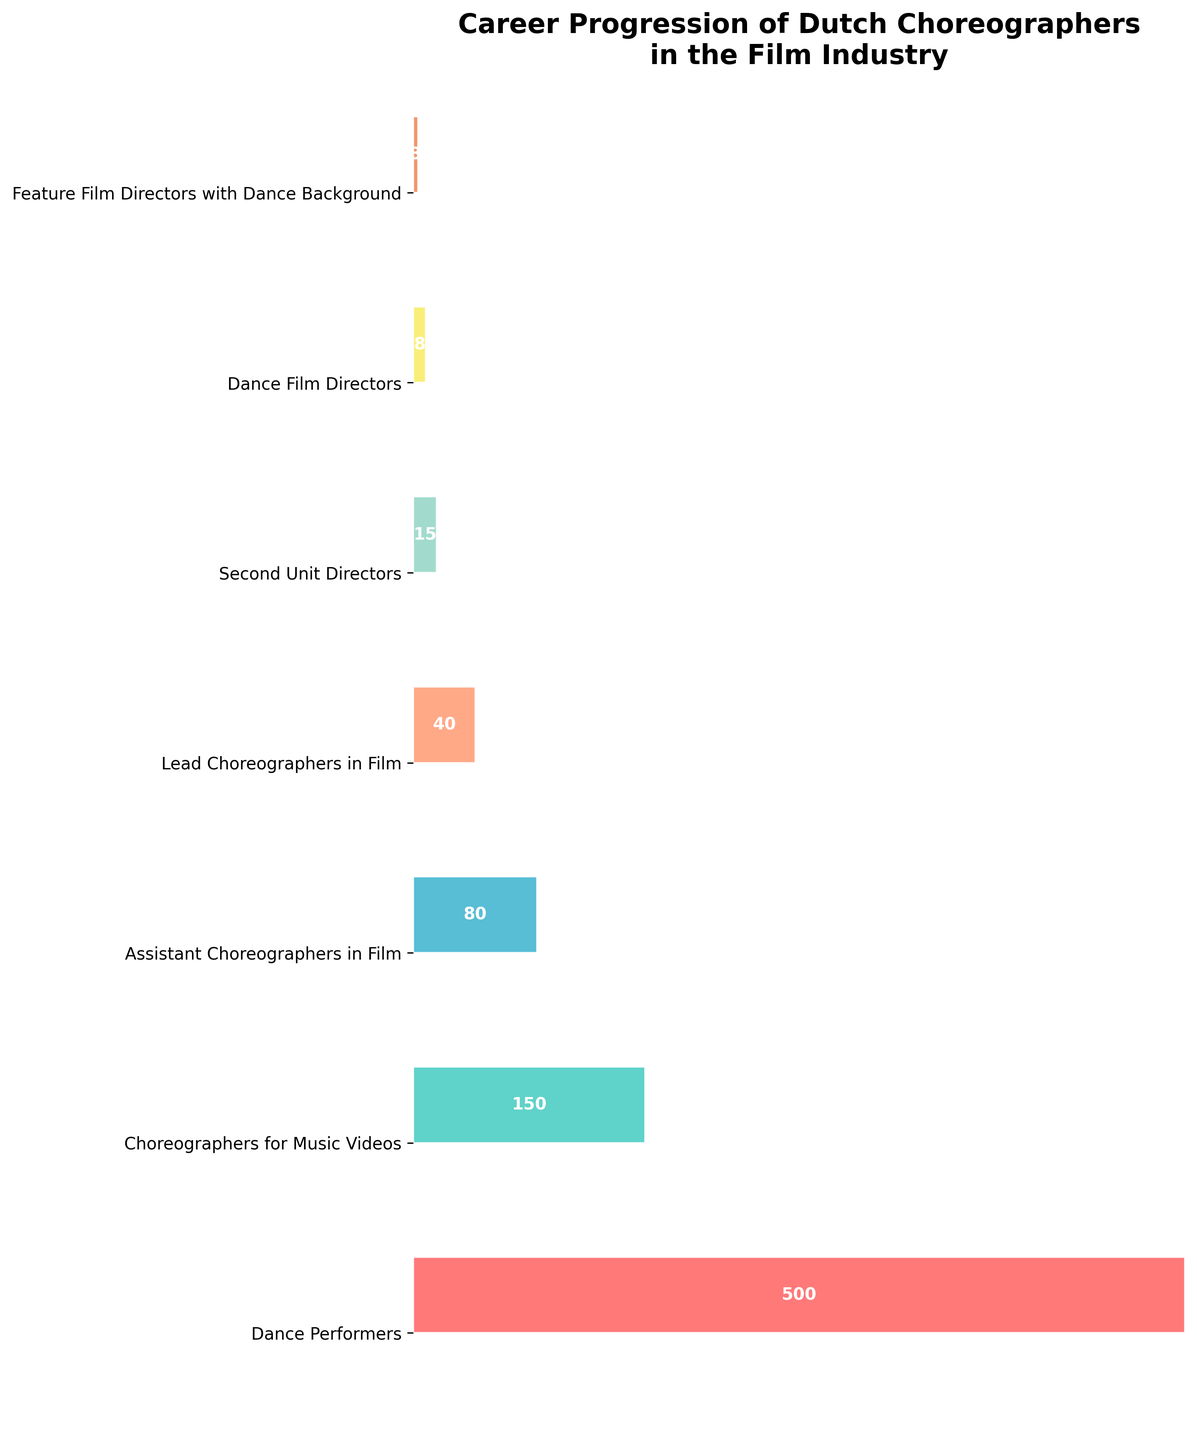What's the title of the funnel chart? The title is often displayed at the top of the figure, summarizing the main theme or the data represented in the chart. In this case, the title should clearly describe the career progression of Dutch choreographers in the film industry.
Answer: Career Progression of Dutch Choreographers in the Film Industry What's the color of the 'Lead Choreographers in Film' stage? Colors in the chart represent different stages. The 'Lead Choreographers in Film' stage is the fourth stage from the bottom and has a unique color.
Answer: #FFA07A How many dance performers move on to become choreographers for music videos? The chart starts with 500 dance performers, and the next stage is 'Choreographers for Music Videos'. The number reduces to 150, indicating the progression from one stage to another.
Answer: 150 Which stage has the fewest number of professionals? By looking at the smallest width in the funnel chart, which corresponds to the number of professionals, we identify the stage with the least professionals.
Answer: Feature Film Directors with Dance Background What percentage of dance performers become choreographers for music videos? Calculate the percentage by dividing the number of 'Choreographers for Music Videos' by the 'Dance Performers' and then multiply by 100. (150/500)*100
Answer: 30% Between which two consecutive stages is the biggest drop in the number of professionals observed? To find the biggest drop, compare the differences in the number of professionals between each consecutive stage and identify the largest value.
Answer: Choreographers for Music Videos to Assistant Choreographers in Film How many more professionals are there in 'Assistant Choreographers in Film' compared to 'Second Unit Directors'? Subtract the number of 'Second Unit Directors' from 'Assistant Choreographers in Film'. 80 - 15 = 65
Answer: 65 If you were to visualize the 'Lead Choreographers in Film' as a percentage of the 'Dance Performers,' what would it be? Calculate the percentage of 'Lead Choreographers in Film' out of 'Dance Performers' by (40/500)*100.
Answer: 8% What is the average number of professionals from the 'Assistant Choreographers in Film' stage to 'Feature Film Directors with Dance Background'? Sum the values (80 + 40 + 15 + 8 + 3) and divide by the number of stages (5). (80 + 40 + 15 + 8 + 3)/5 = 29.2
Answer: 29.2 Compare the number of professionals in 'Dance Performers' to the total number of professionals in all the other stages combined. Which is greater? Sum the number of professionals in all stages except 'Dance Performers' (150 + 80 + 40 + 15 + 8 + 3 = 296) and compare to 'Dance Performers' (500).
Answer: Dance Performers 